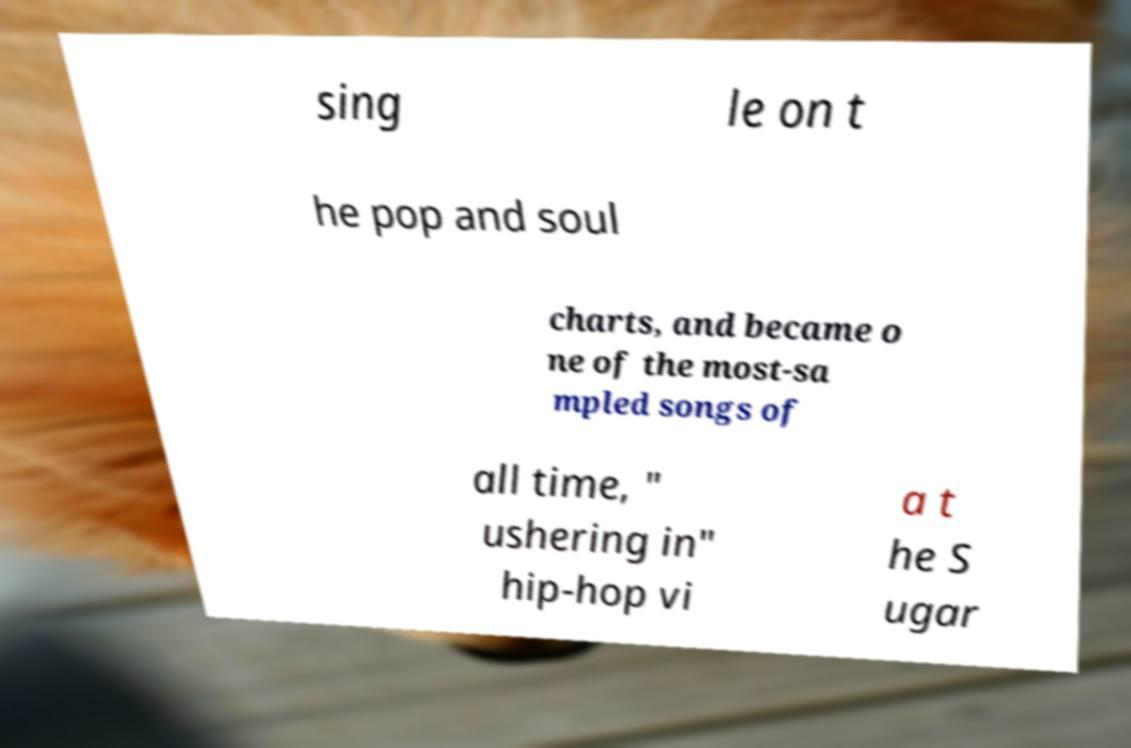Can you accurately transcribe the text from the provided image for me? sing le on t he pop and soul charts, and became o ne of the most-sa mpled songs of all time, " ushering in" hip-hop vi a t he S ugar 